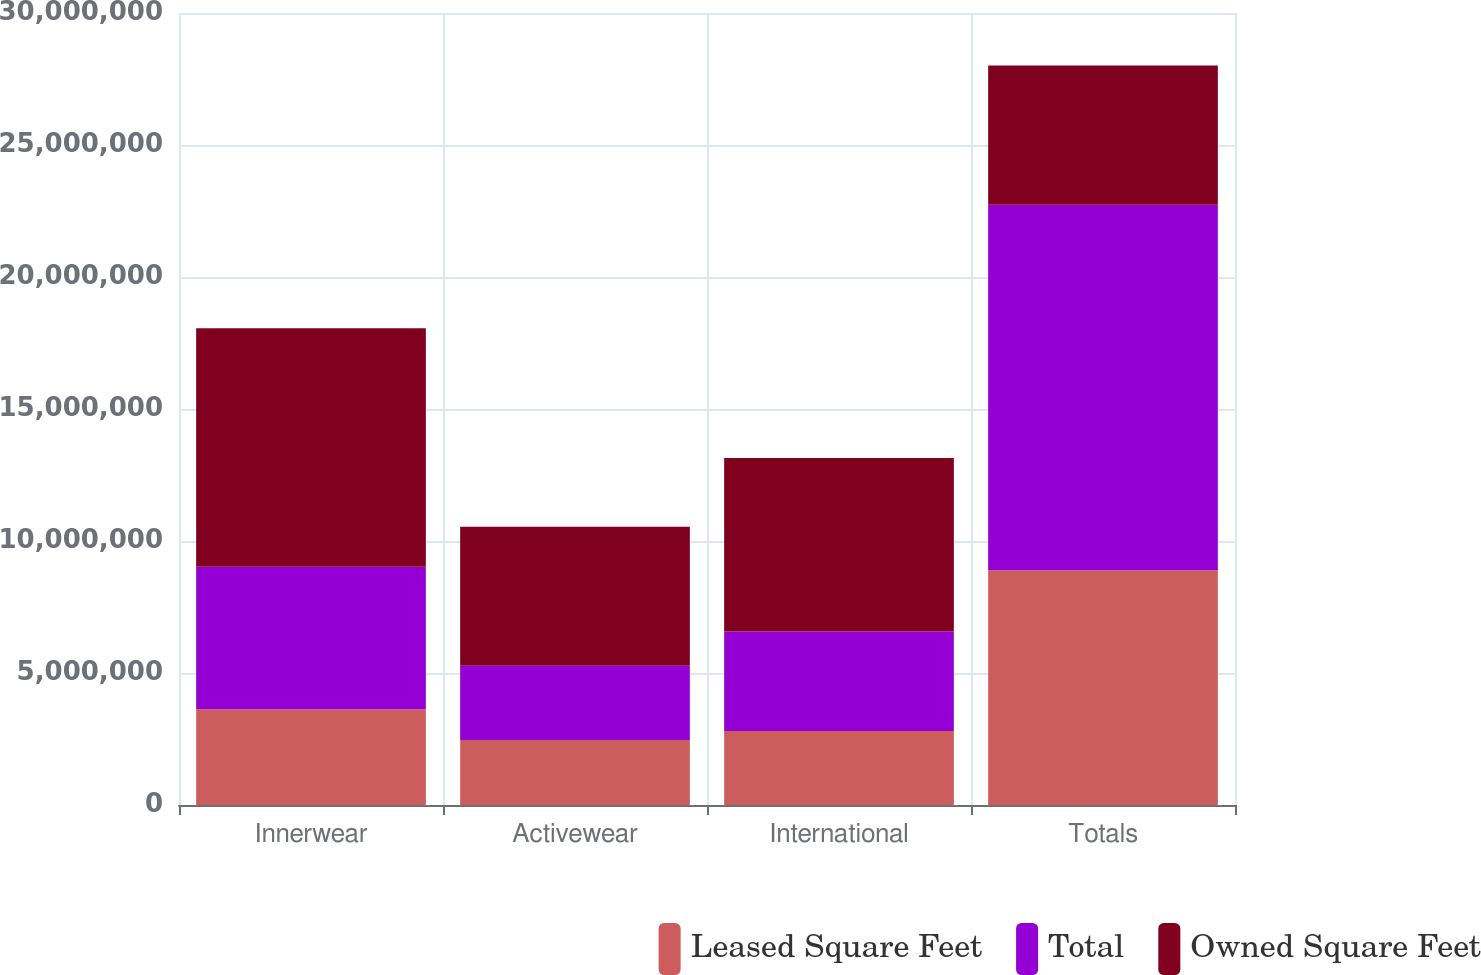Convert chart. <chart><loc_0><loc_0><loc_500><loc_500><stacked_bar_chart><ecel><fcel>Innerwear<fcel>Activewear<fcel>International<fcel>Totals<nl><fcel>Leased Square Feet<fcel>3.62981e+06<fcel>2.45852e+06<fcel>2.80757e+06<fcel>8.8959e+06<nl><fcel>Total<fcel>5.39738e+06<fcel>2.81266e+06<fcel>3.764e+06<fcel>1.38417e+07<nl><fcel>Owned Square Feet<fcel>9.02719e+06<fcel>5.27118e+06<fcel>6.57156e+06<fcel>5.27118e+06<nl></chart> 